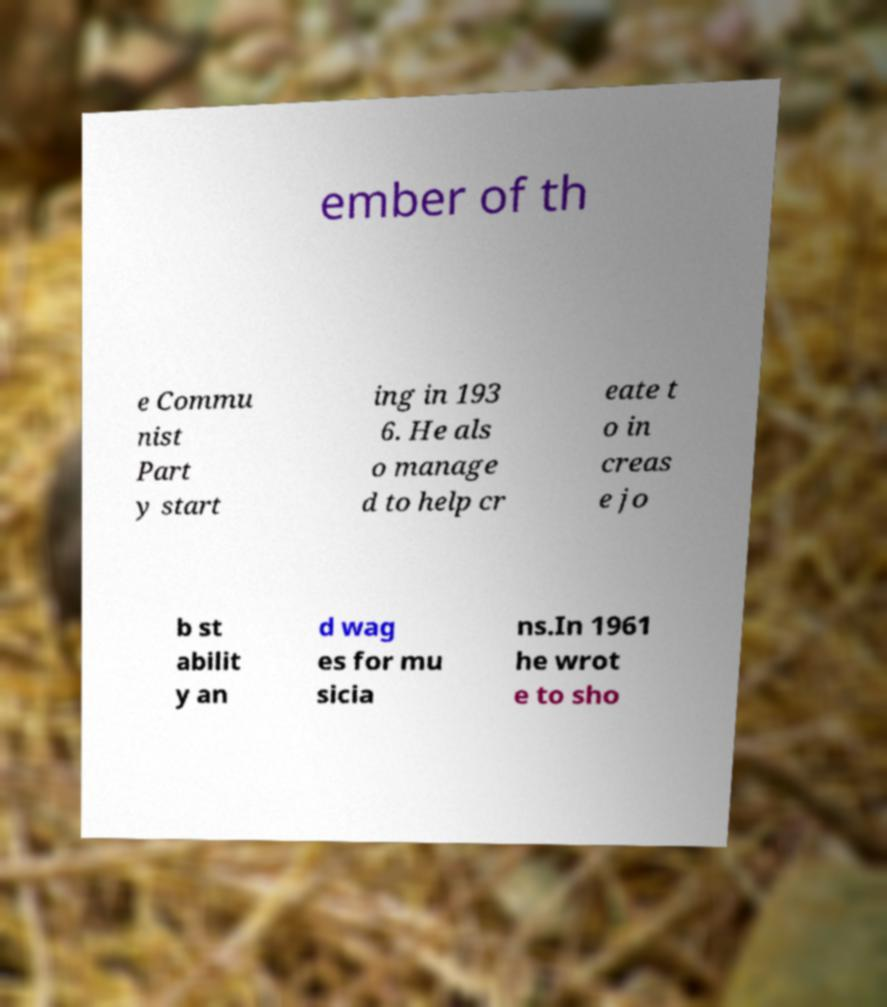Please identify and transcribe the text found in this image. ember of th e Commu nist Part y start ing in 193 6. He als o manage d to help cr eate t o in creas e jo b st abilit y an d wag es for mu sicia ns.In 1961 he wrot e to sho 